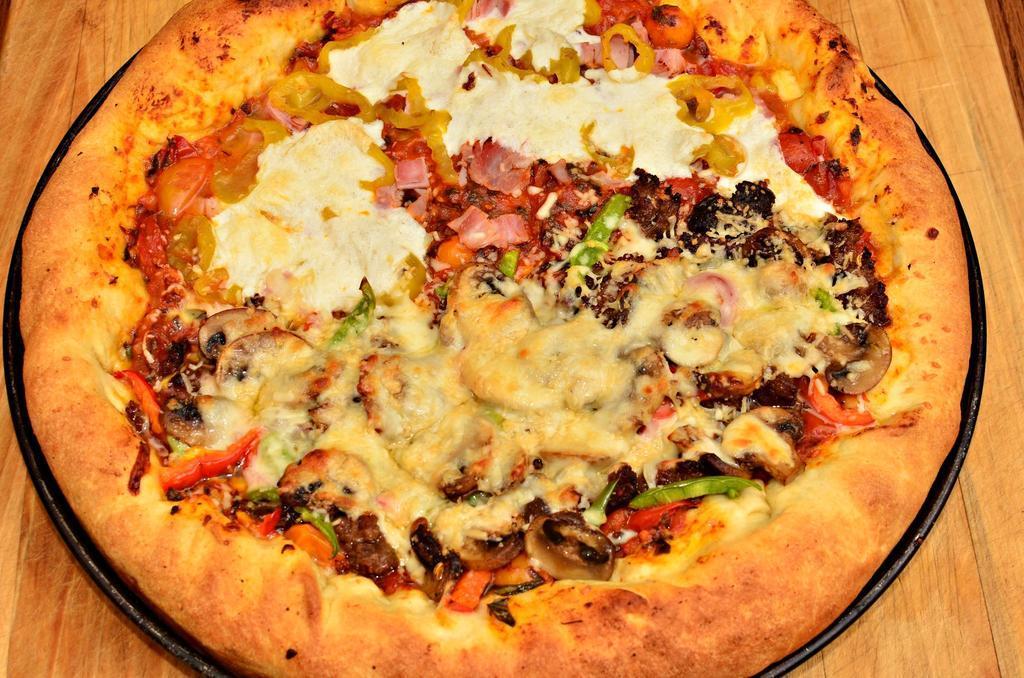Can you describe this image briefly? In this image we can see a pizza in a plate which is placed on the table. 